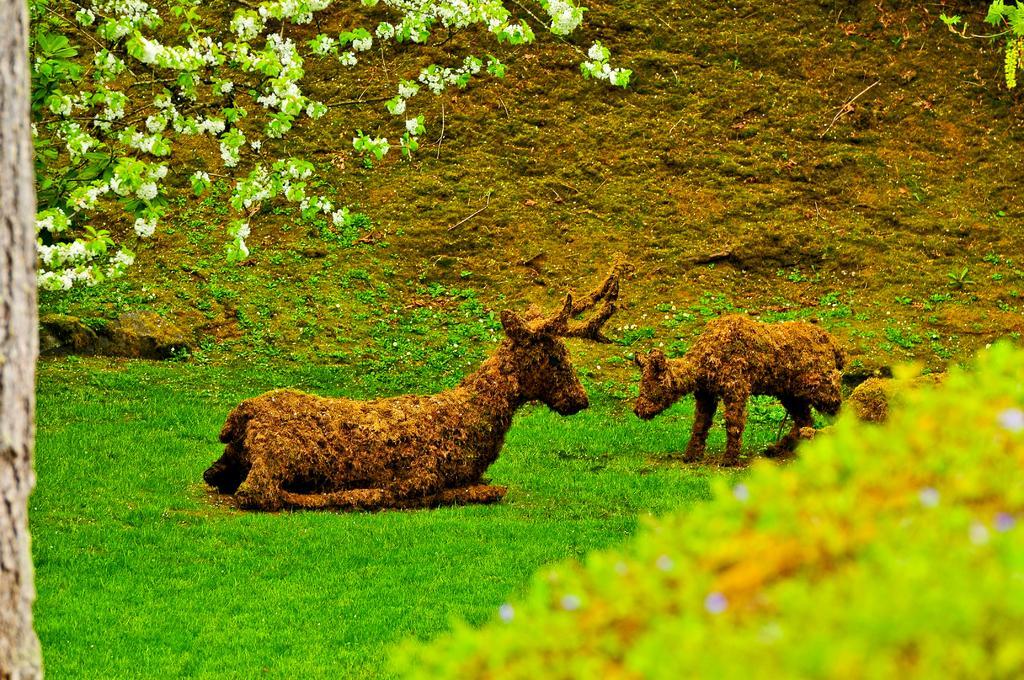In one or two sentences, can you explain what this image depicts? In the center of the image we can see two statues. On the left side of the image, we can see one object. At the bottom right side of the image, we can see it is blurred. In the background, we can see the grass and branches with leaves and flowers. 